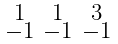<formula> <loc_0><loc_0><loc_500><loc_500>\begin{smallmatrix} 1 & 1 & 3 \\ - 1 & - 1 & - 1 \end{smallmatrix}</formula> 